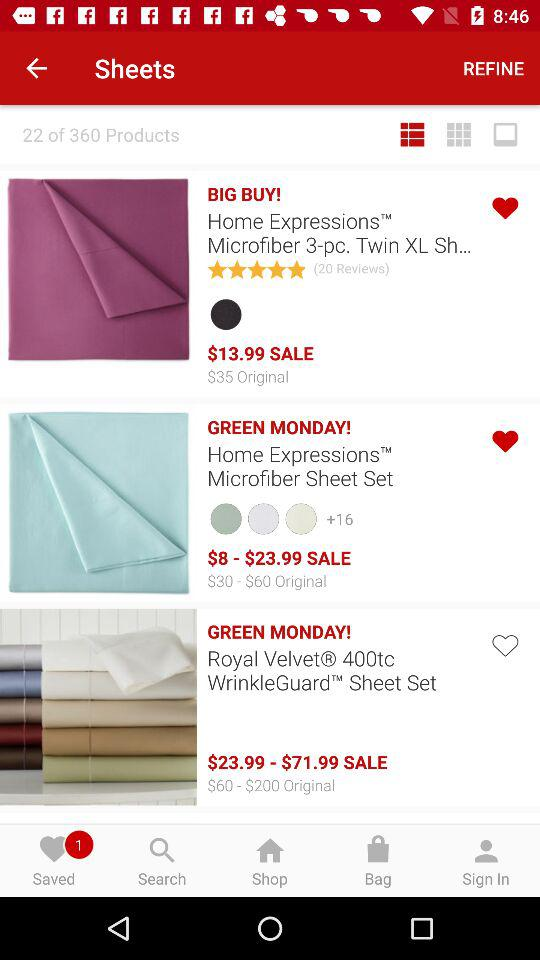How much is the most expensive item on sale? $71.99 